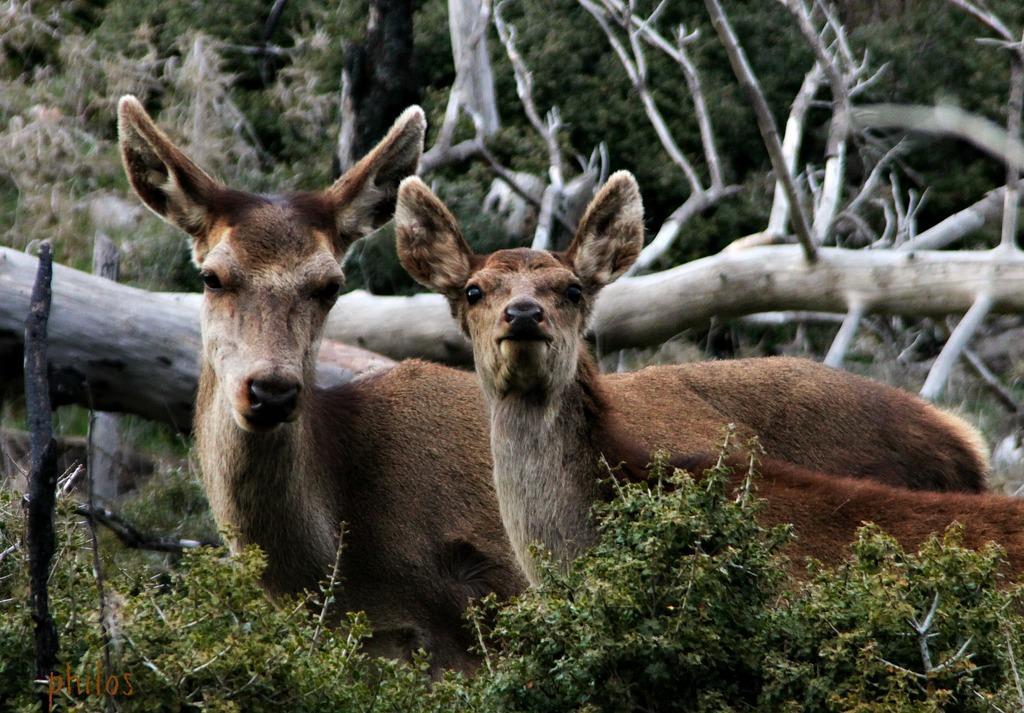In one or two sentences, can you explain what this image depicts? In this image, we can see animals. At the bottom, there are few plants and watermark. Background we can see trees and wooden logs. 